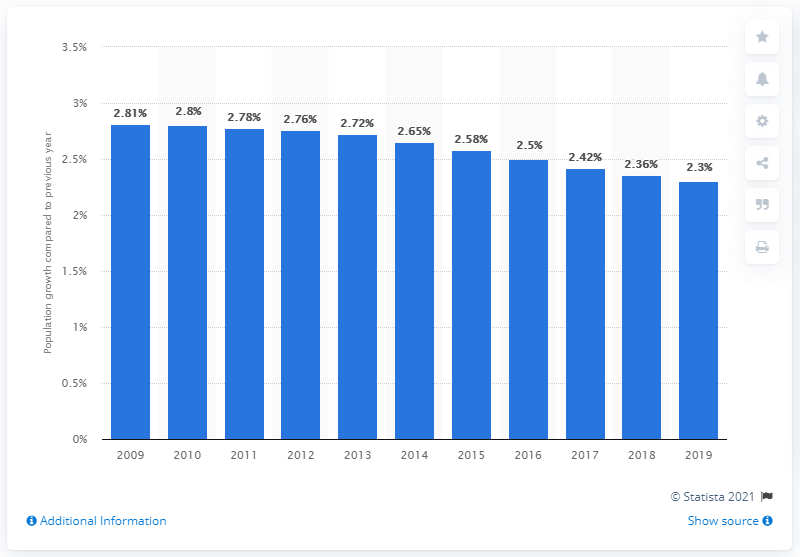Highlight a few significant elements in this photo. Yemen's population increased by 2.3% in 2019. 